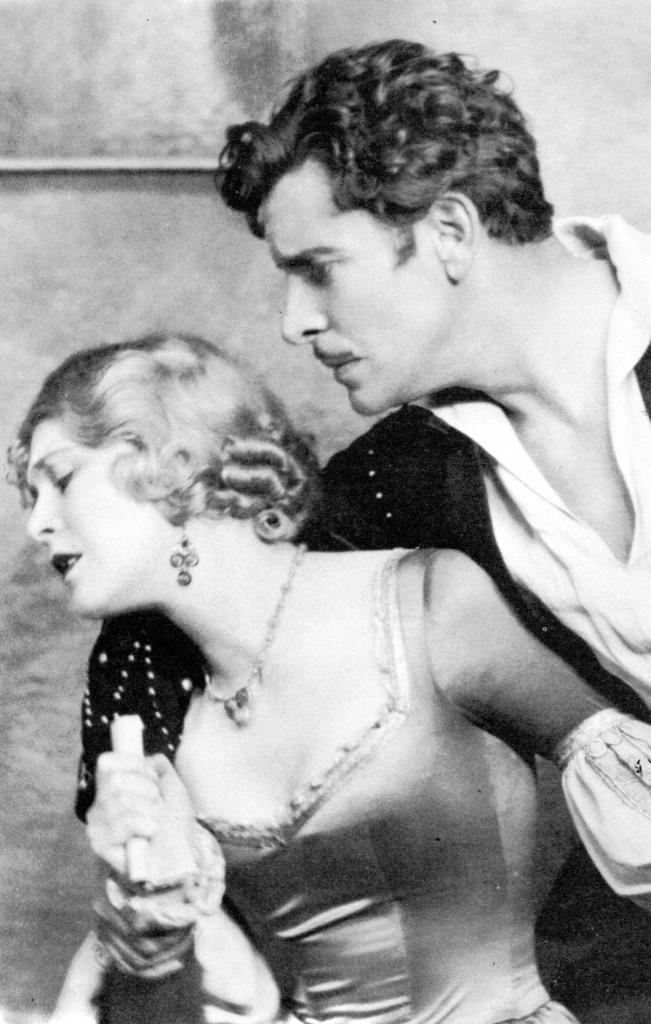Describe this image in one or two sentences. In this image we can see a lady and a man, she is holding an object, behind them, we can see the wall, and the picture is taken in black and white mode. 